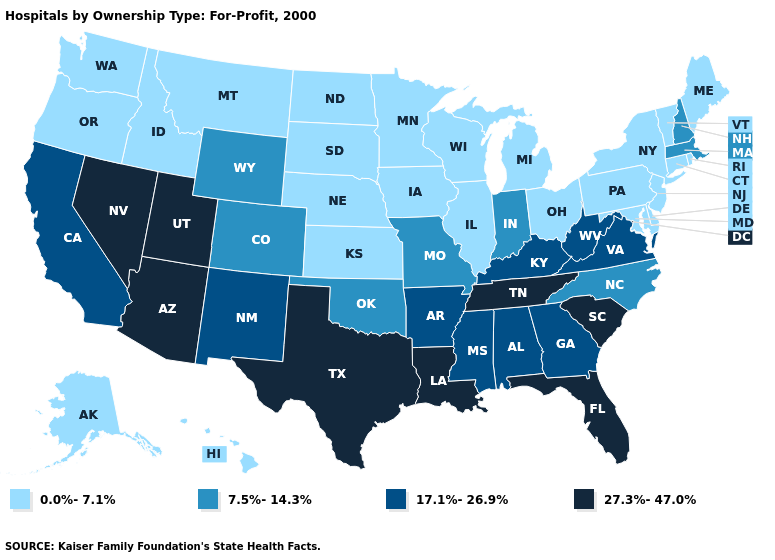Name the states that have a value in the range 17.1%-26.9%?
Quick response, please. Alabama, Arkansas, California, Georgia, Kentucky, Mississippi, New Mexico, Virginia, West Virginia. What is the value of Michigan?
Keep it brief. 0.0%-7.1%. Name the states that have a value in the range 17.1%-26.9%?
Quick response, please. Alabama, Arkansas, California, Georgia, Kentucky, Mississippi, New Mexico, Virginia, West Virginia. What is the value of Montana?
Quick response, please. 0.0%-7.1%. Name the states that have a value in the range 0.0%-7.1%?
Quick response, please. Alaska, Connecticut, Delaware, Hawaii, Idaho, Illinois, Iowa, Kansas, Maine, Maryland, Michigan, Minnesota, Montana, Nebraska, New Jersey, New York, North Dakota, Ohio, Oregon, Pennsylvania, Rhode Island, South Dakota, Vermont, Washington, Wisconsin. What is the value of Utah?
Answer briefly. 27.3%-47.0%. Name the states that have a value in the range 17.1%-26.9%?
Concise answer only. Alabama, Arkansas, California, Georgia, Kentucky, Mississippi, New Mexico, Virginia, West Virginia. What is the lowest value in the Northeast?
Give a very brief answer. 0.0%-7.1%. What is the highest value in states that border Idaho?
Give a very brief answer. 27.3%-47.0%. Does New Hampshire have the lowest value in the Northeast?
Answer briefly. No. Does Georgia have a lower value than Arizona?
Give a very brief answer. Yes. Does Wisconsin have the lowest value in the USA?
Concise answer only. Yes. Which states have the lowest value in the USA?
Quick response, please. Alaska, Connecticut, Delaware, Hawaii, Idaho, Illinois, Iowa, Kansas, Maine, Maryland, Michigan, Minnesota, Montana, Nebraska, New Jersey, New York, North Dakota, Ohio, Oregon, Pennsylvania, Rhode Island, South Dakota, Vermont, Washington, Wisconsin. Does South Carolina have the lowest value in the USA?
Answer briefly. No. 